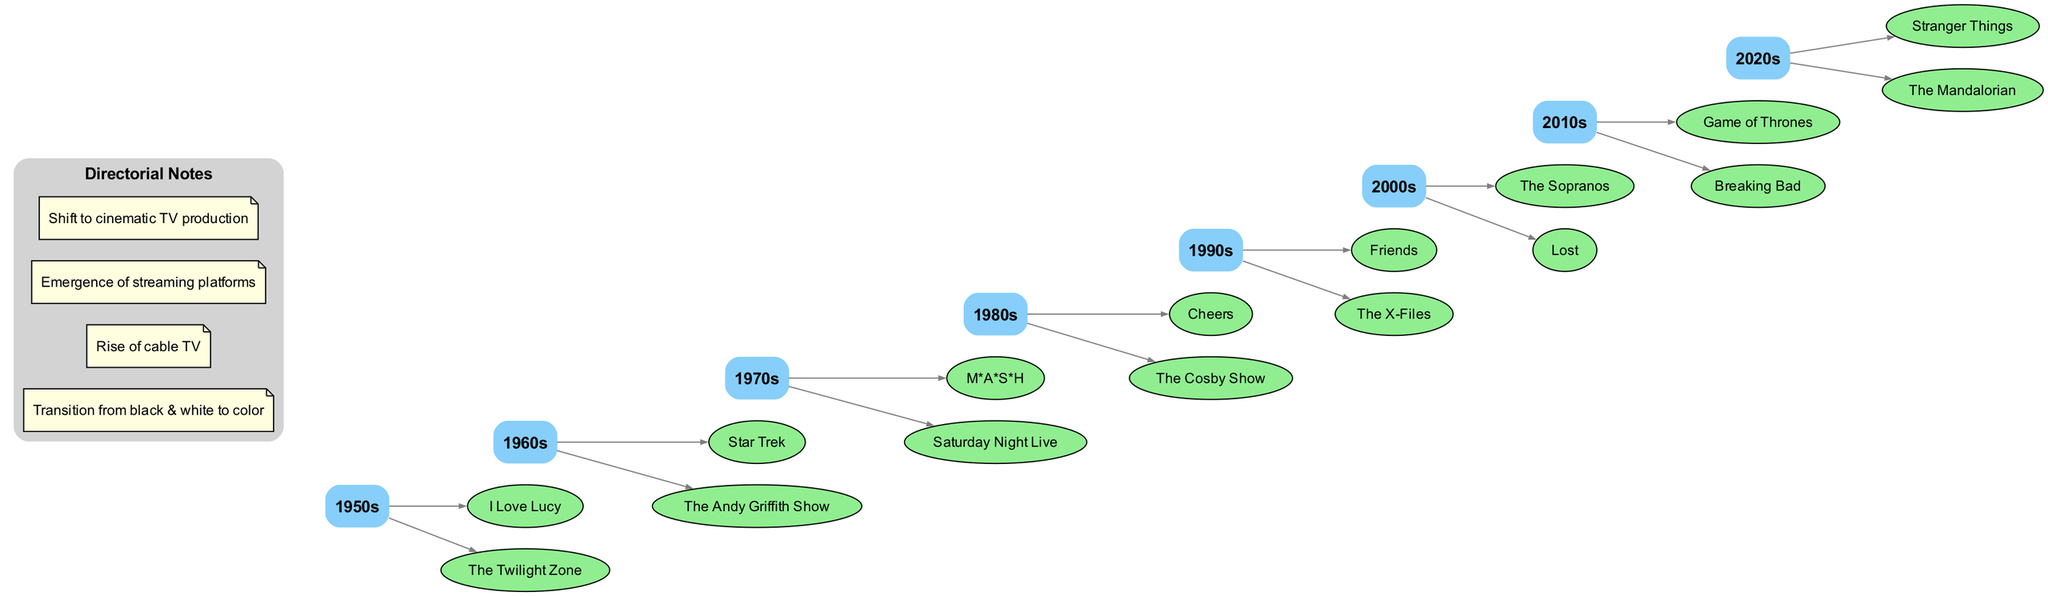What iconic television show premiered in the 1980s? By reviewing the shows listed under the 1980s node in the diagram, we can identify "Cheers" and "The Cosby Show" as iconic television shows of that decade.
Answer: Cheers How many iconic shows are listed for the 1960s? The diagram shows two shows listed under the 1960s, "Star Trek" and "The Andy Griffith Show." Therefore, the count of shows is two.
Answer: 2 Which decade features "Friends"? By locating the show "Friends" within the timeline, it is found under the 1990s decade. Thus, the decade featuring "Friends" is the 1990s.
Answer: 1990s What change occurred from the 1950s to the 1960s regarding television shows? Observing the timeline, the directorial notes indicate a transition from black & white to color television during this period. Thus, the change refers to the shift in production standards.
Answer: Transition from black & white to color Which show is listed directly after "M*A*S*H" in the timeline? By examining the 1970s section in the diagram, we see "M*A*S*H" followed by "Saturday Night Live." Therefore, the show that comes directly after "M*A*S*H" is "Saturday Night Live."
Answer: Saturday Night Live What was a significant development in television by the 2000s according to the directorial notes? The directorial notes highlight the emergence of streaming platforms as a significant development in television during the 2000s, indicating a major shift in how shows were distributed and consumed.
Answer: Emergence of streaming platforms Which two shows are associated with the decade of the 2010s? Looking at the 2010s node, the shows listed are "Game of Thrones" and "Breaking Bad." Therefore, both of these shows are associated with the decade of the 2010s.
Answer: Game of Thrones, Breaking Bad What is the total number of decades represented in the diagram? The diagram lists seven decades from the 1950s to the 2020s. Therefore, the total number of decades represented in the diagram is eight (including both the starting and ending points).
Answer: 8 Which decade has the iconic show "Lost"? By inspecting the timeline, "Lost" is found under the 2000s node. Thus, the decade that has "Lost" listed is the 2000s.
Answer: 2000s 